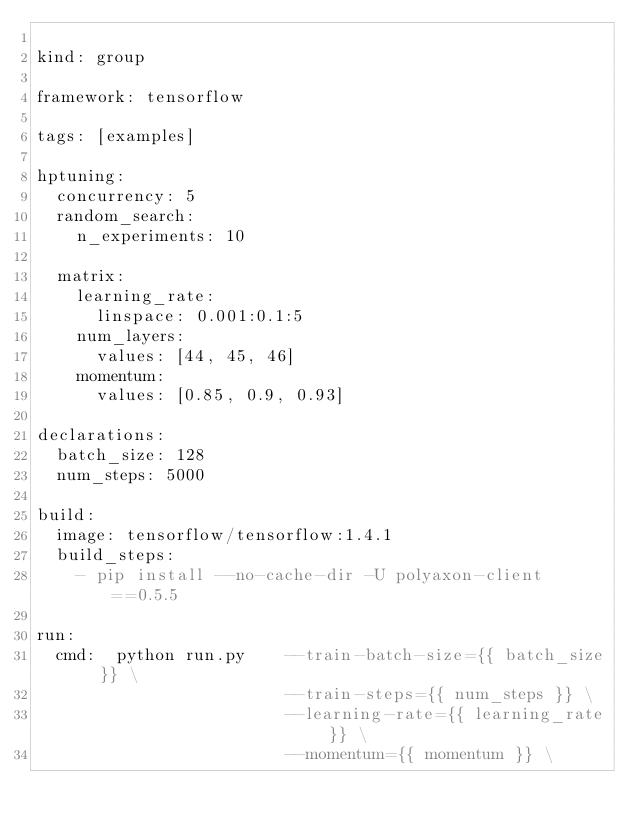<code> <loc_0><loc_0><loc_500><loc_500><_YAML_>
kind: group

framework: tensorflow

tags: [examples]

hptuning:
  concurrency: 5
  random_search:
    n_experiments: 10

  matrix:
    learning_rate:
      linspace: 0.001:0.1:5
    num_layers:
      values: [44, 45, 46]
    momentum:
      values: [0.85, 0.9, 0.93]

declarations:
  batch_size: 128
  num_steps: 5000

build:
  image: tensorflow/tensorflow:1.4.1
  build_steps:
    - pip install --no-cache-dir -U polyaxon-client==0.5.5

run:
  cmd:  python run.py    --train-batch-size={{ batch_size }} \
                         --train-steps={{ num_steps }} \
                         --learning-rate={{ learning_rate }} \
                         --momentum={{ momentum }} \
</code> 